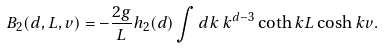Convert formula to latex. <formula><loc_0><loc_0><loc_500><loc_500>B _ { 2 } ( d , L , v ) = - \frac { 2 g } { L } h _ { 2 } ( d ) \int d k \, k ^ { d - 3 } \coth k L \cosh k v .</formula> 